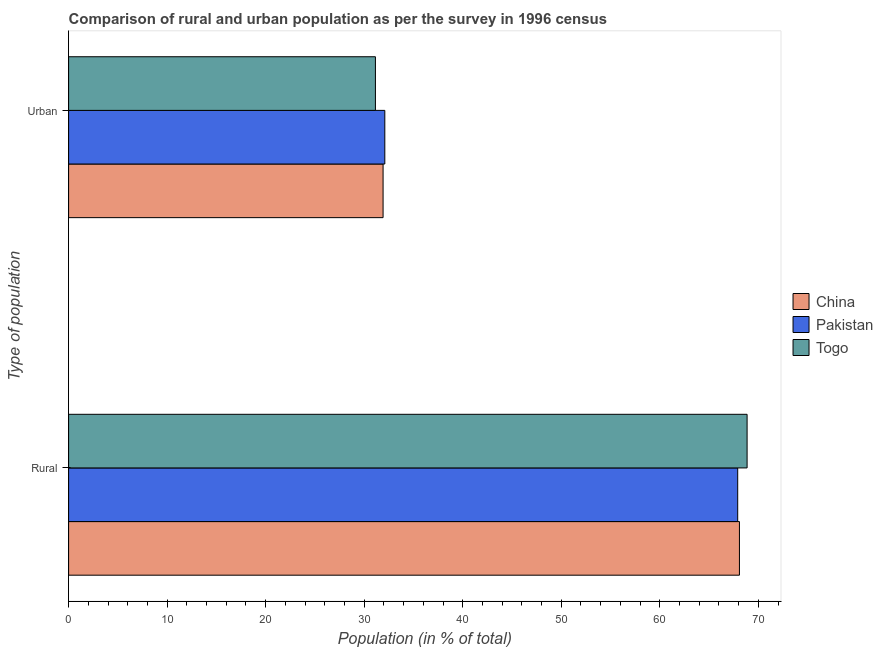Are the number of bars per tick equal to the number of legend labels?
Provide a succinct answer. Yes. What is the label of the 2nd group of bars from the top?
Ensure brevity in your answer.  Rural. What is the rural population in Togo?
Make the answer very short. 68.86. Across all countries, what is the maximum rural population?
Ensure brevity in your answer.  68.86. Across all countries, what is the minimum rural population?
Make the answer very short. 67.91. In which country was the rural population maximum?
Offer a very short reply. Togo. What is the total rural population in the graph?
Your response must be concise. 204.85. What is the difference between the rural population in Pakistan and that in Togo?
Offer a very short reply. -0.95. What is the difference between the urban population in Pakistan and the rural population in China?
Ensure brevity in your answer.  -35.99. What is the average rural population per country?
Your response must be concise. 68.28. What is the difference between the urban population and rural population in Togo?
Provide a short and direct response. -37.72. What is the ratio of the urban population in China to that in Togo?
Offer a very short reply. 1.02. Is the urban population in Togo less than that in China?
Your response must be concise. Yes. What does the 1st bar from the bottom in Urban represents?
Keep it short and to the point. China. How many bars are there?
Offer a very short reply. 6. Are the values on the major ticks of X-axis written in scientific E-notation?
Ensure brevity in your answer.  No. Does the graph contain any zero values?
Offer a terse response. No. Does the graph contain grids?
Offer a very short reply. No. Where does the legend appear in the graph?
Give a very brief answer. Center right. How are the legend labels stacked?
Offer a terse response. Vertical. What is the title of the graph?
Keep it short and to the point. Comparison of rural and urban population as per the survey in 1996 census. What is the label or title of the X-axis?
Make the answer very short. Population (in % of total). What is the label or title of the Y-axis?
Provide a succinct answer. Type of population. What is the Population (in % of total) in China in Rural?
Offer a terse response. 68.08. What is the Population (in % of total) of Pakistan in Rural?
Keep it short and to the point. 67.91. What is the Population (in % of total) in Togo in Rural?
Keep it short and to the point. 68.86. What is the Population (in % of total) of China in Urban?
Provide a succinct answer. 31.92. What is the Population (in % of total) in Pakistan in Urban?
Provide a succinct answer. 32.09. What is the Population (in % of total) of Togo in Urban?
Make the answer very short. 31.14. Across all Type of population, what is the maximum Population (in % of total) of China?
Your response must be concise. 68.08. Across all Type of population, what is the maximum Population (in % of total) in Pakistan?
Your answer should be compact. 67.91. Across all Type of population, what is the maximum Population (in % of total) in Togo?
Offer a terse response. 68.86. Across all Type of population, what is the minimum Population (in % of total) of China?
Give a very brief answer. 31.92. Across all Type of population, what is the minimum Population (in % of total) in Pakistan?
Ensure brevity in your answer.  32.09. Across all Type of population, what is the minimum Population (in % of total) in Togo?
Your answer should be very brief. 31.14. What is the total Population (in % of total) in China in the graph?
Offer a terse response. 100. What is the total Population (in % of total) in Pakistan in the graph?
Ensure brevity in your answer.  100. What is the difference between the Population (in % of total) of China in Rural and that in Urban?
Your response must be concise. 36.17. What is the difference between the Population (in % of total) of Pakistan in Rural and that in Urban?
Offer a very short reply. 35.82. What is the difference between the Population (in % of total) in Togo in Rural and that in Urban?
Keep it short and to the point. 37.72. What is the difference between the Population (in % of total) of China in Rural and the Population (in % of total) of Pakistan in Urban?
Offer a very short reply. 35.99. What is the difference between the Population (in % of total) of China in Rural and the Population (in % of total) of Togo in Urban?
Keep it short and to the point. 36.95. What is the difference between the Population (in % of total) in Pakistan in Rural and the Population (in % of total) in Togo in Urban?
Offer a terse response. 36.77. What is the average Population (in % of total) in China per Type of population?
Offer a terse response. 50. What is the average Population (in % of total) of Pakistan per Type of population?
Your answer should be very brief. 50. What is the difference between the Population (in % of total) of China and Population (in % of total) of Pakistan in Rural?
Ensure brevity in your answer.  0.18. What is the difference between the Population (in % of total) in China and Population (in % of total) in Togo in Rural?
Offer a very short reply. -0.78. What is the difference between the Population (in % of total) of Pakistan and Population (in % of total) of Togo in Rural?
Offer a terse response. -0.95. What is the difference between the Population (in % of total) of China and Population (in % of total) of Pakistan in Urban?
Offer a very short reply. -0.18. What is the difference between the Population (in % of total) of China and Population (in % of total) of Togo in Urban?
Make the answer very short. 0.78. What is the difference between the Population (in % of total) in Pakistan and Population (in % of total) in Togo in Urban?
Provide a succinct answer. 0.95. What is the ratio of the Population (in % of total) of China in Rural to that in Urban?
Offer a terse response. 2.13. What is the ratio of the Population (in % of total) of Pakistan in Rural to that in Urban?
Give a very brief answer. 2.12. What is the ratio of the Population (in % of total) of Togo in Rural to that in Urban?
Offer a very short reply. 2.21. What is the difference between the highest and the second highest Population (in % of total) of China?
Make the answer very short. 36.17. What is the difference between the highest and the second highest Population (in % of total) in Pakistan?
Give a very brief answer. 35.82. What is the difference between the highest and the second highest Population (in % of total) of Togo?
Provide a short and direct response. 37.72. What is the difference between the highest and the lowest Population (in % of total) in China?
Offer a terse response. 36.17. What is the difference between the highest and the lowest Population (in % of total) of Pakistan?
Your answer should be very brief. 35.82. What is the difference between the highest and the lowest Population (in % of total) of Togo?
Make the answer very short. 37.72. 